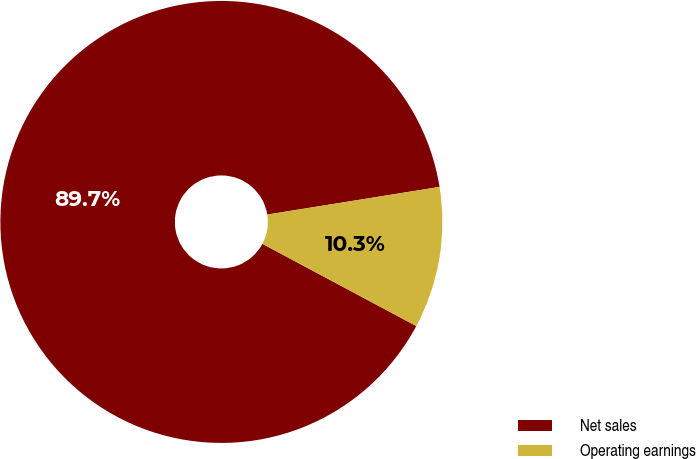Convert chart. <chart><loc_0><loc_0><loc_500><loc_500><pie_chart><fcel>Net sales<fcel>Operating earnings<nl><fcel>89.66%<fcel>10.34%<nl></chart> 